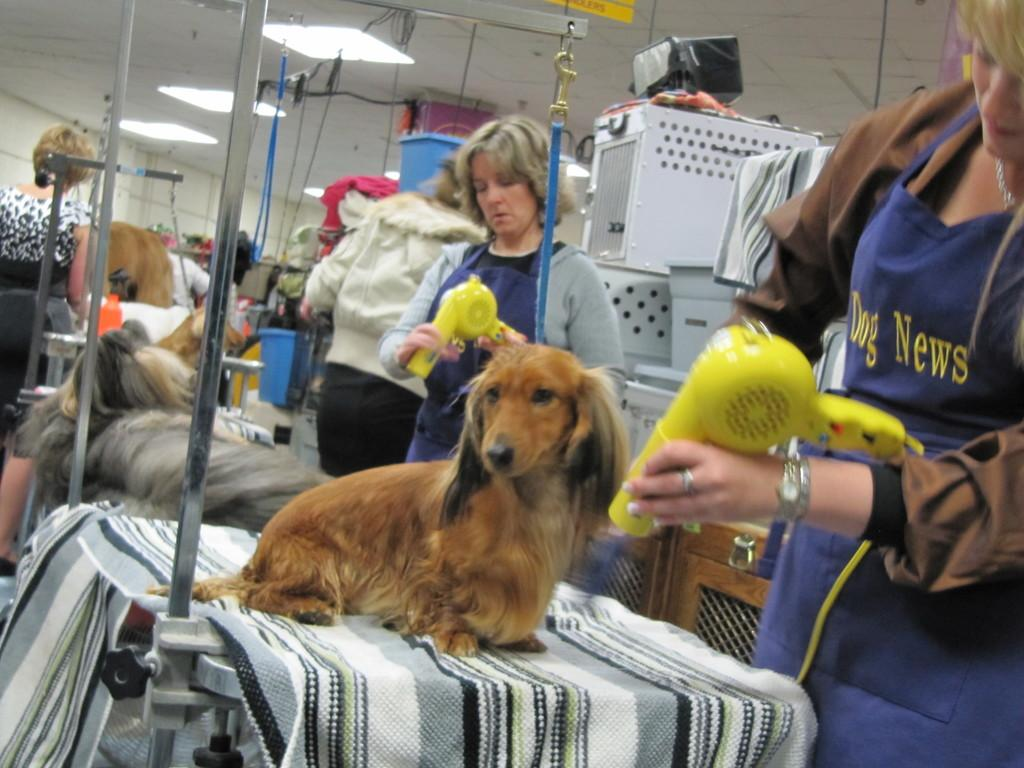What type of animal is in the image? There is a dog in the image. What color is the dog? The dog is brown in color. Who is present in the image besides the dog? There is a woman standing on the right side of the image. What is the woman doing in the image? The woman is looking at the dog. How many eggs are being held by the rabbits in the image? There are no rabbits or eggs present in the image. 